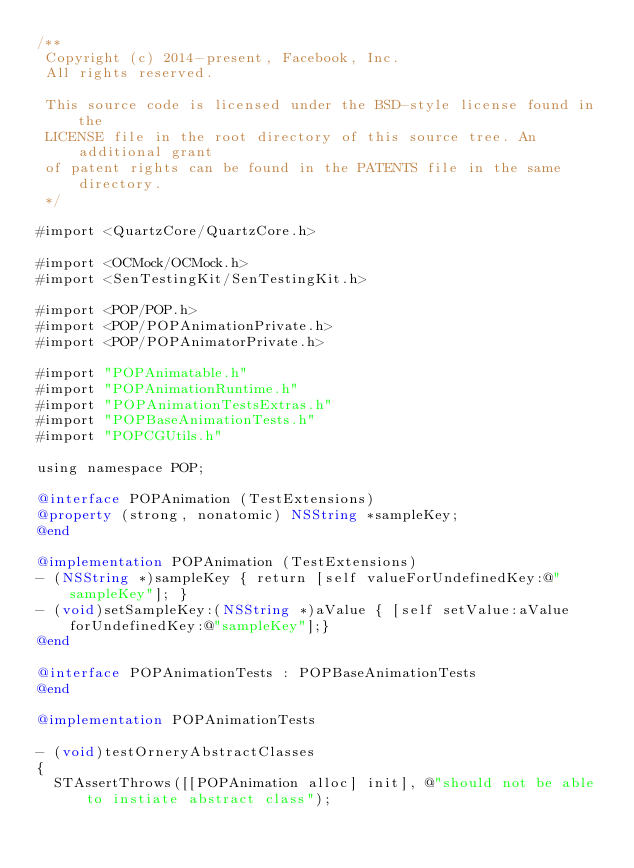<code> <loc_0><loc_0><loc_500><loc_500><_ObjectiveC_>/**
 Copyright (c) 2014-present, Facebook, Inc.
 All rights reserved.
 
 This source code is licensed under the BSD-style license found in the
 LICENSE file in the root directory of this source tree. An additional grant
 of patent rights can be found in the PATENTS file in the same directory.
 */

#import <QuartzCore/QuartzCore.h>

#import <OCMock/OCMock.h>
#import <SenTestingKit/SenTestingKit.h>

#import <POP/POP.h>
#import <POP/POPAnimationPrivate.h>
#import <POP/POPAnimatorPrivate.h>

#import "POPAnimatable.h"
#import "POPAnimationRuntime.h"
#import "POPAnimationTestsExtras.h"
#import "POPBaseAnimationTests.h"
#import "POPCGUtils.h"

using namespace POP;

@interface POPAnimation (TestExtensions)
@property (strong, nonatomic) NSString *sampleKey;
@end

@implementation POPAnimation (TestExtensions)
- (NSString *)sampleKey { return [self valueForUndefinedKey:@"sampleKey"]; }
- (void)setSampleKey:(NSString *)aValue { [self setValue:aValue forUndefinedKey:@"sampleKey"];}
@end

@interface POPAnimationTests : POPBaseAnimationTests
@end

@implementation POPAnimationTests

- (void)testOrneryAbstractClasses
{
  STAssertThrows([[POPAnimation alloc] init], @"should not be able to instiate abstract class");</code> 